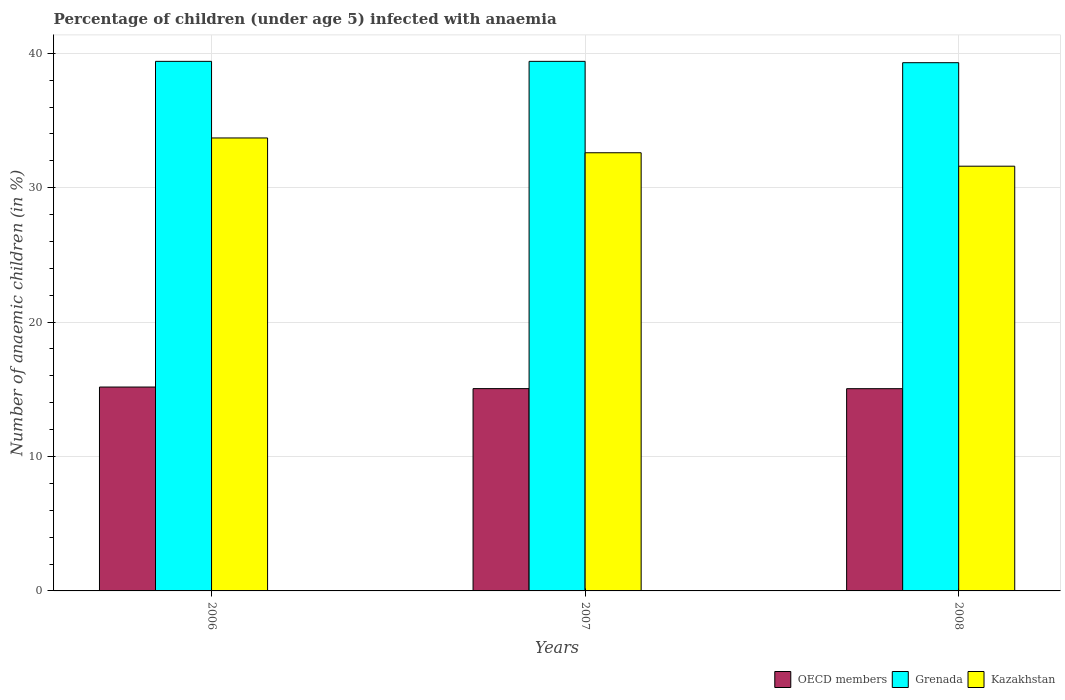How many different coloured bars are there?
Ensure brevity in your answer.  3. Are the number of bars on each tick of the X-axis equal?
Ensure brevity in your answer.  Yes. What is the percentage of children infected with anaemia in in OECD members in 2006?
Your answer should be very brief. 15.17. Across all years, what is the maximum percentage of children infected with anaemia in in Kazakhstan?
Make the answer very short. 33.7. Across all years, what is the minimum percentage of children infected with anaemia in in Grenada?
Offer a terse response. 39.3. In which year was the percentage of children infected with anaemia in in Grenada maximum?
Your answer should be very brief. 2006. In which year was the percentage of children infected with anaemia in in Grenada minimum?
Provide a short and direct response. 2008. What is the total percentage of children infected with anaemia in in OECD members in the graph?
Your answer should be very brief. 45.27. What is the difference between the percentage of children infected with anaemia in in OECD members in 2007 and that in 2008?
Your response must be concise. 0. What is the difference between the percentage of children infected with anaemia in in Kazakhstan in 2007 and the percentage of children infected with anaemia in in OECD members in 2008?
Your answer should be very brief. 17.55. What is the average percentage of children infected with anaemia in in Grenada per year?
Ensure brevity in your answer.  39.37. In the year 2008, what is the difference between the percentage of children infected with anaemia in in Grenada and percentage of children infected with anaemia in in OECD members?
Ensure brevity in your answer.  24.25. In how many years, is the percentage of children infected with anaemia in in Kazakhstan greater than 16 %?
Keep it short and to the point. 3. What is the ratio of the percentage of children infected with anaemia in in Grenada in 2006 to that in 2007?
Give a very brief answer. 1. Is the percentage of children infected with anaemia in in Grenada in 2007 less than that in 2008?
Offer a terse response. No. Is the difference between the percentage of children infected with anaemia in in Grenada in 2007 and 2008 greater than the difference between the percentage of children infected with anaemia in in OECD members in 2007 and 2008?
Offer a very short reply. Yes. What is the difference between the highest and the second highest percentage of children infected with anaemia in in Kazakhstan?
Keep it short and to the point. 1.1. What is the difference between the highest and the lowest percentage of children infected with anaemia in in Kazakhstan?
Your response must be concise. 2.1. What does the 2nd bar from the left in 2008 represents?
Give a very brief answer. Grenada. What does the 1st bar from the right in 2007 represents?
Ensure brevity in your answer.  Kazakhstan. How many bars are there?
Provide a short and direct response. 9. Are all the bars in the graph horizontal?
Your answer should be very brief. No. How many years are there in the graph?
Your response must be concise. 3. What is the difference between two consecutive major ticks on the Y-axis?
Ensure brevity in your answer.  10. Does the graph contain grids?
Offer a very short reply. Yes. Where does the legend appear in the graph?
Keep it short and to the point. Bottom right. How are the legend labels stacked?
Give a very brief answer. Horizontal. What is the title of the graph?
Offer a very short reply. Percentage of children (under age 5) infected with anaemia. Does "Sint Maarten (Dutch part)" appear as one of the legend labels in the graph?
Ensure brevity in your answer.  No. What is the label or title of the Y-axis?
Keep it short and to the point. Number of anaemic children (in %). What is the Number of anaemic children (in %) of OECD members in 2006?
Provide a succinct answer. 15.17. What is the Number of anaemic children (in %) of Grenada in 2006?
Keep it short and to the point. 39.4. What is the Number of anaemic children (in %) of Kazakhstan in 2006?
Offer a terse response. 33.7. What is the Number of anaemic children (in %) of OECD members in 2007?
Make the answer very short. 15.05. What is the Number of anaemic children (in %) of Grenada in 2007?
Your answer should be very brief. 39.4. What is the Number of anaemic children (in %) of Kazakhstan in 2007?
Provide a succinct answer. 32.6. What is the Number of anaemic children (in %) in OECD members in 2008?
Provide a short and direct response. 15.05. What is the Number of anaemic children (in %) of Grenada in 2008?
Give a very brief answer. 39.3. What is the Number of anaemic children (in %) of Kazakhstan in 2008?
Offer a very short reply. 31.6. Across all years, what is the maximum Number of anaemic children (in %) in OECD members?
Provide a short and direct response. 15.17. Across all years, what is the maximum Number of anaemic children (in %) in Grenada?
Provide a succinct answer. 39.4. Across all years, what is the maximum Number of anaemic children (in %) of Kazakhstan?
Your answer should be very brief. 33.7. Across all years, what is the minimum Number of anaemic children (in %) of OECD members?
Provide a short and direct response. 15.05. Across all years, what is the minimum Number of anaemic children (in %) in Grenada?
Your answer should be compact. 39.3. Across all years, what is the minimum Number of anaemic children (in %) of Kazakhstan?
Provide a short and direct response. 31.6. What is the total Number of anaemic children (in %) of OECD members in the graph?
Provide a succinct answer. 45.27. What is the total Number of anaemic children (in %) in Grenada in the graph?
Offer a terse response. 118.1. What is the total Number of anaemic children (in %) of Kazakhstan in the graph?
Your response must be concise. 97.9. What is the difference between the Number of anaemic children (in %) of OECD members in 2006 and that in 2007?
Provide a short and direct response. 0.12. What is the difference between the Number of anaemic children (in %) of OECD members in 2006 and that in 2008?
Ensure brevity in your answer.  0.12. What is the difference between the Number of anaemic children (in %) of OECD members in 2007 and that in 2008?
Your answer should be very brief. 0. What is the difference between the Number of anaemic children (in %) in Grenada in 2007 and that in 2008?
Your response must be concise. 0.1. What is the difference between the Number of anaemic children (in %) of OECD members in 2006 and the Number of anaemic children (in %) of Grenada in 2007?
Give a very brief answer. -24.23. What is the difference between the Number of anaemic children (in %) of OECD members in 2006 and the Number of anaemic children (in %) of Kazakhstan in 2007?
Provide a succinct answer. -17.43. What is the difference between the Number of anaemic children (in %) of Grenada in 2006 and the Number of anaemic children (in %) of Kazakhstan in 2007?
Your response must be concise. 6.8. What is the difference between the Number of anaemic children (in %) in OECD members in 2006 and the Number of anaemic children (in %) in Grenada in 2008?
Your answer should be very brief. -24.13. What is the difference between the Number of anaemic children (in %) in OECD members in 2006 and the Number of anaemic children (in %) in Kazakhstan in 2008?
Your answer should be compact. -16.43. What is the difference between the Number of anaemic children (in %) of OECD members in 2007 and the Number of anaemic children (in %) of Grenada in 2008?
Provide a succinct answer. -24.25. What is the difference between the Number of anaemic children (in %) in OECD members in 2007 and the Number of anaemic children (in %) in Kazakhstan in 2008?
Ensure brevity in your answer.  -16.55. What is the average Number of anaemic children (in %) of OECD members per year?
Make the answer very short. 15.09. What is the average Number of anaemic children (in %) in Grenada per year?
Your answer should be compact. 39.37. What is the average Number of anaemic children (in %) in Kazakhstan per year?
Give a very brief answer. 32.63. In the year 2006, what is the difference between the Number of anaemic children (in %) in OECD members and Number of anaemic children (in %) in Grenada?
Keep it short and to the point. -24.23. In the year 2006, what is the difference between the Number of anaemic children (in %) in OECD members and Number of anaemic children (in %) in Kazakhstan?
Provide a succinct answer. -18.53. In the year 2007, what is the difference between the Number of anaemic children (in %) in OECD members and Number of anaemic children (in %) in Grenada?
Offer a very short reply. -24.35. In the year 2007, what is the difference between the Number of anaemic children (in %) in OECD members and Number of anaemic children (in %) in Kazakhstan?
Ensure brevity in your answer.  -17.55. In the year 2007, what is the difference between the Number of anaemic children (in %) of Grenada and Number of anaemic children (in %) of Kazakhstan?
Make the answer very short. 6.8. In the year 2008, what is the difference between the Number of anaemic children (in %) of OECD members and Number of anaemic children (in %) of Grenada?
Keep it short and to the point. -24.25. In the year 2008, what is the difference between the Number of anaemic children (in %) of OECD members and Number of anaemic children (in %) of Kazakhstan?
Offer a very short reply. -16.55. What is the ratio of the Number of anaemic children (in %) of Kazakhstan in 2006 to that in 2007?
Provide a succinct answer. 1.03. What is the ratio of the Number of anaemic children (in %) of Kazakhstan in 2006 to that in 2008?
Offer a very short reply. 1.07. What is the ratio of the Number of anaemic children (in %) in Grenada in 2007 to that in 2008?
Give a very brief answer. 1. What is the ratio of the Number of anaemic children (in %) of Kazakhstan in 2007 to that in 2008?
Offer a terse response. 1.03. What is the difference between the highest and the second highest Number of anaemic children (in %) in OECD members?
Provide a succinct answer. 0.12. What is the difference between the highest and the lowest Number of anaemic children (in %) of OECD members?
Keep it short and to the point. 0.12. What is the difference between the highest and the lowest Number of anaemic children (in %) in Grenada?
Keep it short and to the point. 0.1. What is the difference between the highest and the lowest Number of anaemic children (in %) of Kazakhstan?
Offer a very short reply. 2.1. 